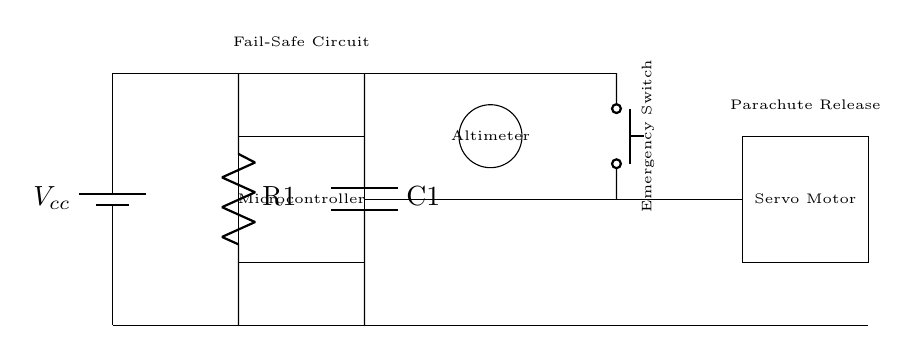What type of microcontroller is used in this circuit? The circuit diagram shows a rectangle labeled "Microcontroller," indicating a microcontroller is present but does not specify the type. Therefore, the type remains unspecified.
Answer: Unspecified What is the function of the emergency switch in this design? The emergency switch is a push button connected to the circuit, which activates the fail-safe landing system for the drone. When pressed, it would trigger the emergency protocols including releasing the parachute.
Answer: Activate fail-safe What is the purpose of the altimeter in this circuit? The altimeter sensor is represented as a circle labeled “Altimeter”. Its purpose is to measure the altitude of the drone and provide feedback to the microcontroller to determine if an emergency landing is necessary.
Answer: Measure altitude What happens to the servo motor when the emergency switch is activated? When the emergency switch is pressed, it completes the circuit, allowing the microcontroller to signal the servo motor to release the parachute for emergency landing. This connection enables the motor to perform its task during emergencies.
Answer: Releases parachute How is the fail-safe mechanism supported in the circuit? The fail-safe mechanism is illustrated by resistors and capacitors labeled R1 and C1, which are essential for stabilizing the circuit and preventing failure during unexpected conditions, ensuring reliability in emergencies.
Answer: Stabilizes circuit 